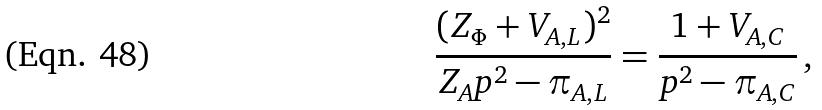Convert formula to latex. <formula><loc_0><loc_0><loc_500><loc_500>\frac { ( Z _ { \Phi } + V _ { A , L } ) ^ { 2 } } { Z _ { A } p ^ { 2 } - \pi _ { A , L } } = \frac { 1 + V _ { A , C } } { p ^ { 2 } - \pi _ { A , C } } \, ,</formula> 